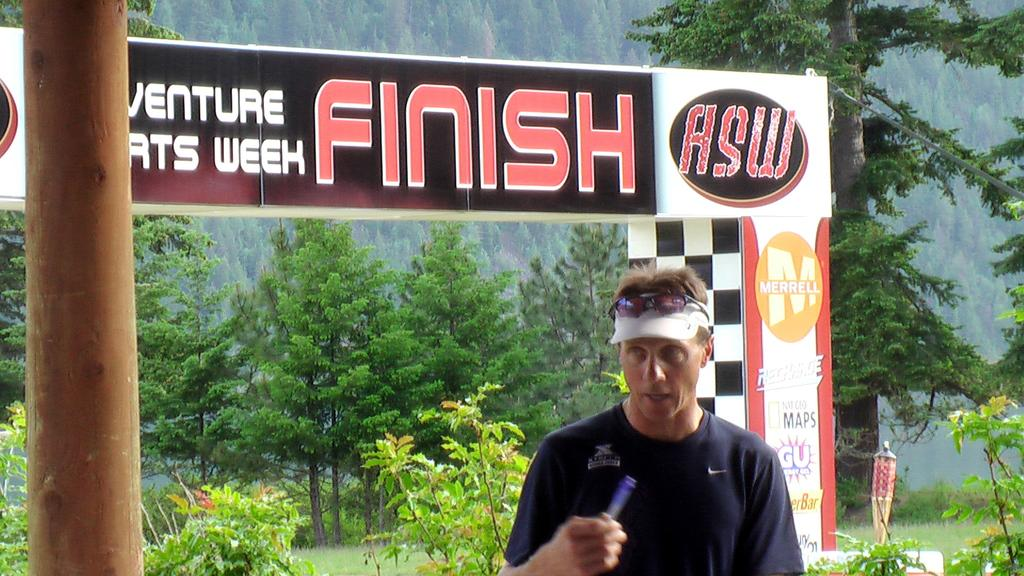Who is present in the image? There is a man in the image. What is the man wearing? The man is wearing a blue t-shirt. What can be seen in the image besides the man? There is a banner in the image. What type of natural environment is visible in the background of the image? There are trees and grass in the background of the image. What type of library can be seen in the background of the image? There is no library present in the image; the background features trees and grass. How many men are visible in the image? There is only one man visible in the image. 